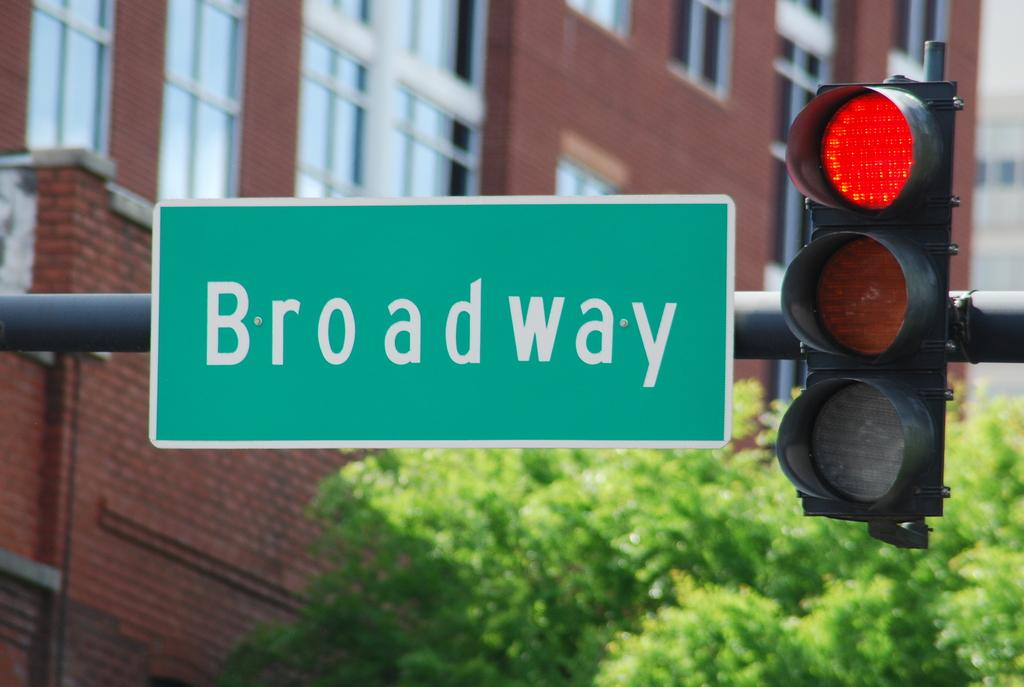<image>
Share a concise interpretation of the image provided. The traffic light at Broadway street is showing red. 